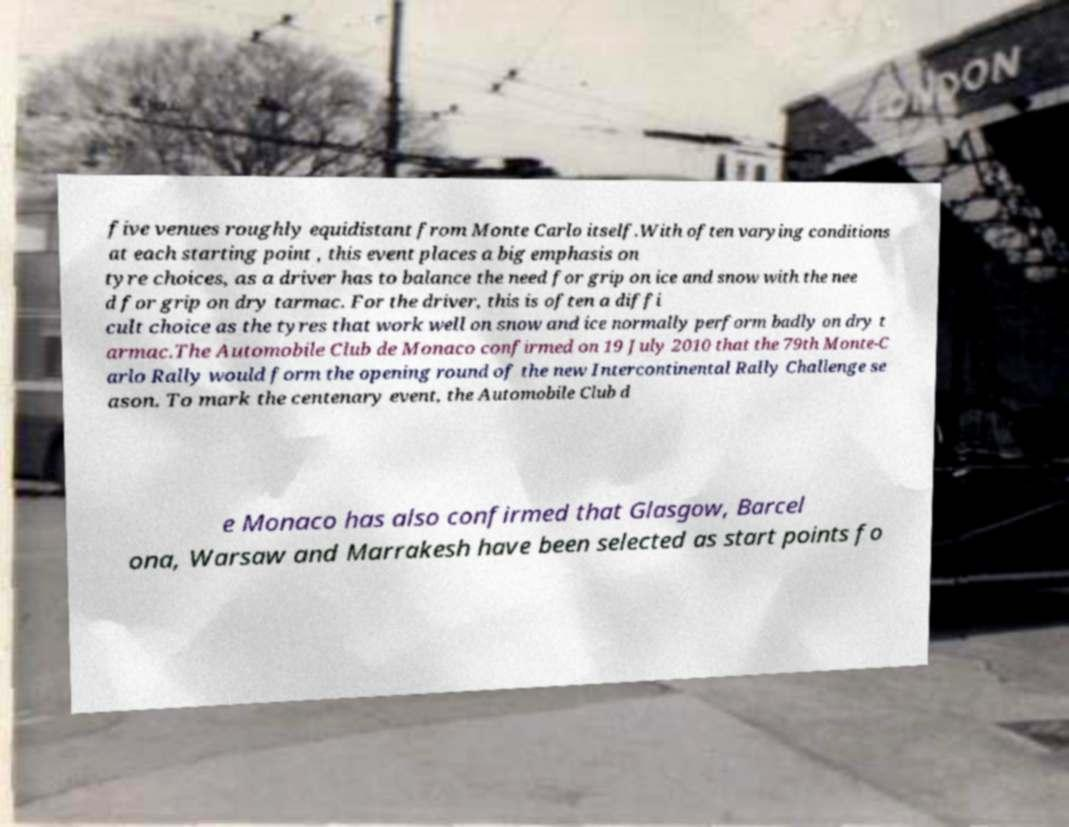What messages or text are displayed in this image? I need them in a readable, typed format. five venues roughly equidistant from Monte Carlo itself.With often varying conditions at each starting point , this event places a big emphasis on tyre choices, as a driver has to balance the need for grip on ice and snow with the nee d for grip on dry tarmac. For the driver, this is often a diffi cult choice as the tyres that work well on snow and ice normally perform badly on dry t armac.The Automobile Club de Monaco confirmed on 19 July 2010 that the 79th Monte-C arlo Rally would form the opening round of the new Intercontinental Rally Challenge se ason. To mark the centenary event, the Automobile Club d e Monaco has also confirmed that Glasgow, Barcel ona, Warsaw and Marrakesh have been selected as start points fo 